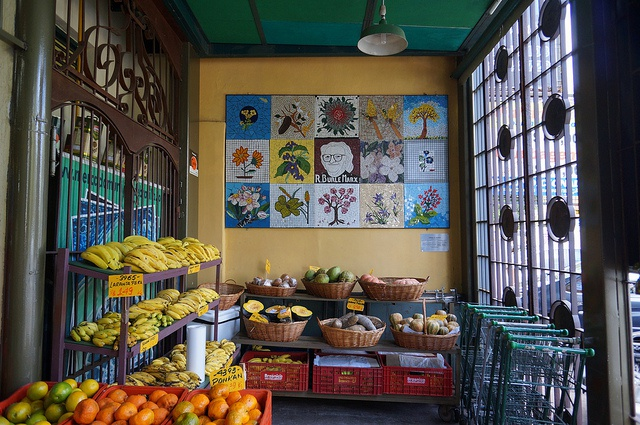Describe the objects in this image and their specific colors. I can see orange in black, red, orange, and maroon tones, orange in black, red, maroon, brown, and orange tones, bowl in black, maroon, and gray tones, bowl in black, maroon, gray, and brown tones, and banana in black and olive tones in this image. 